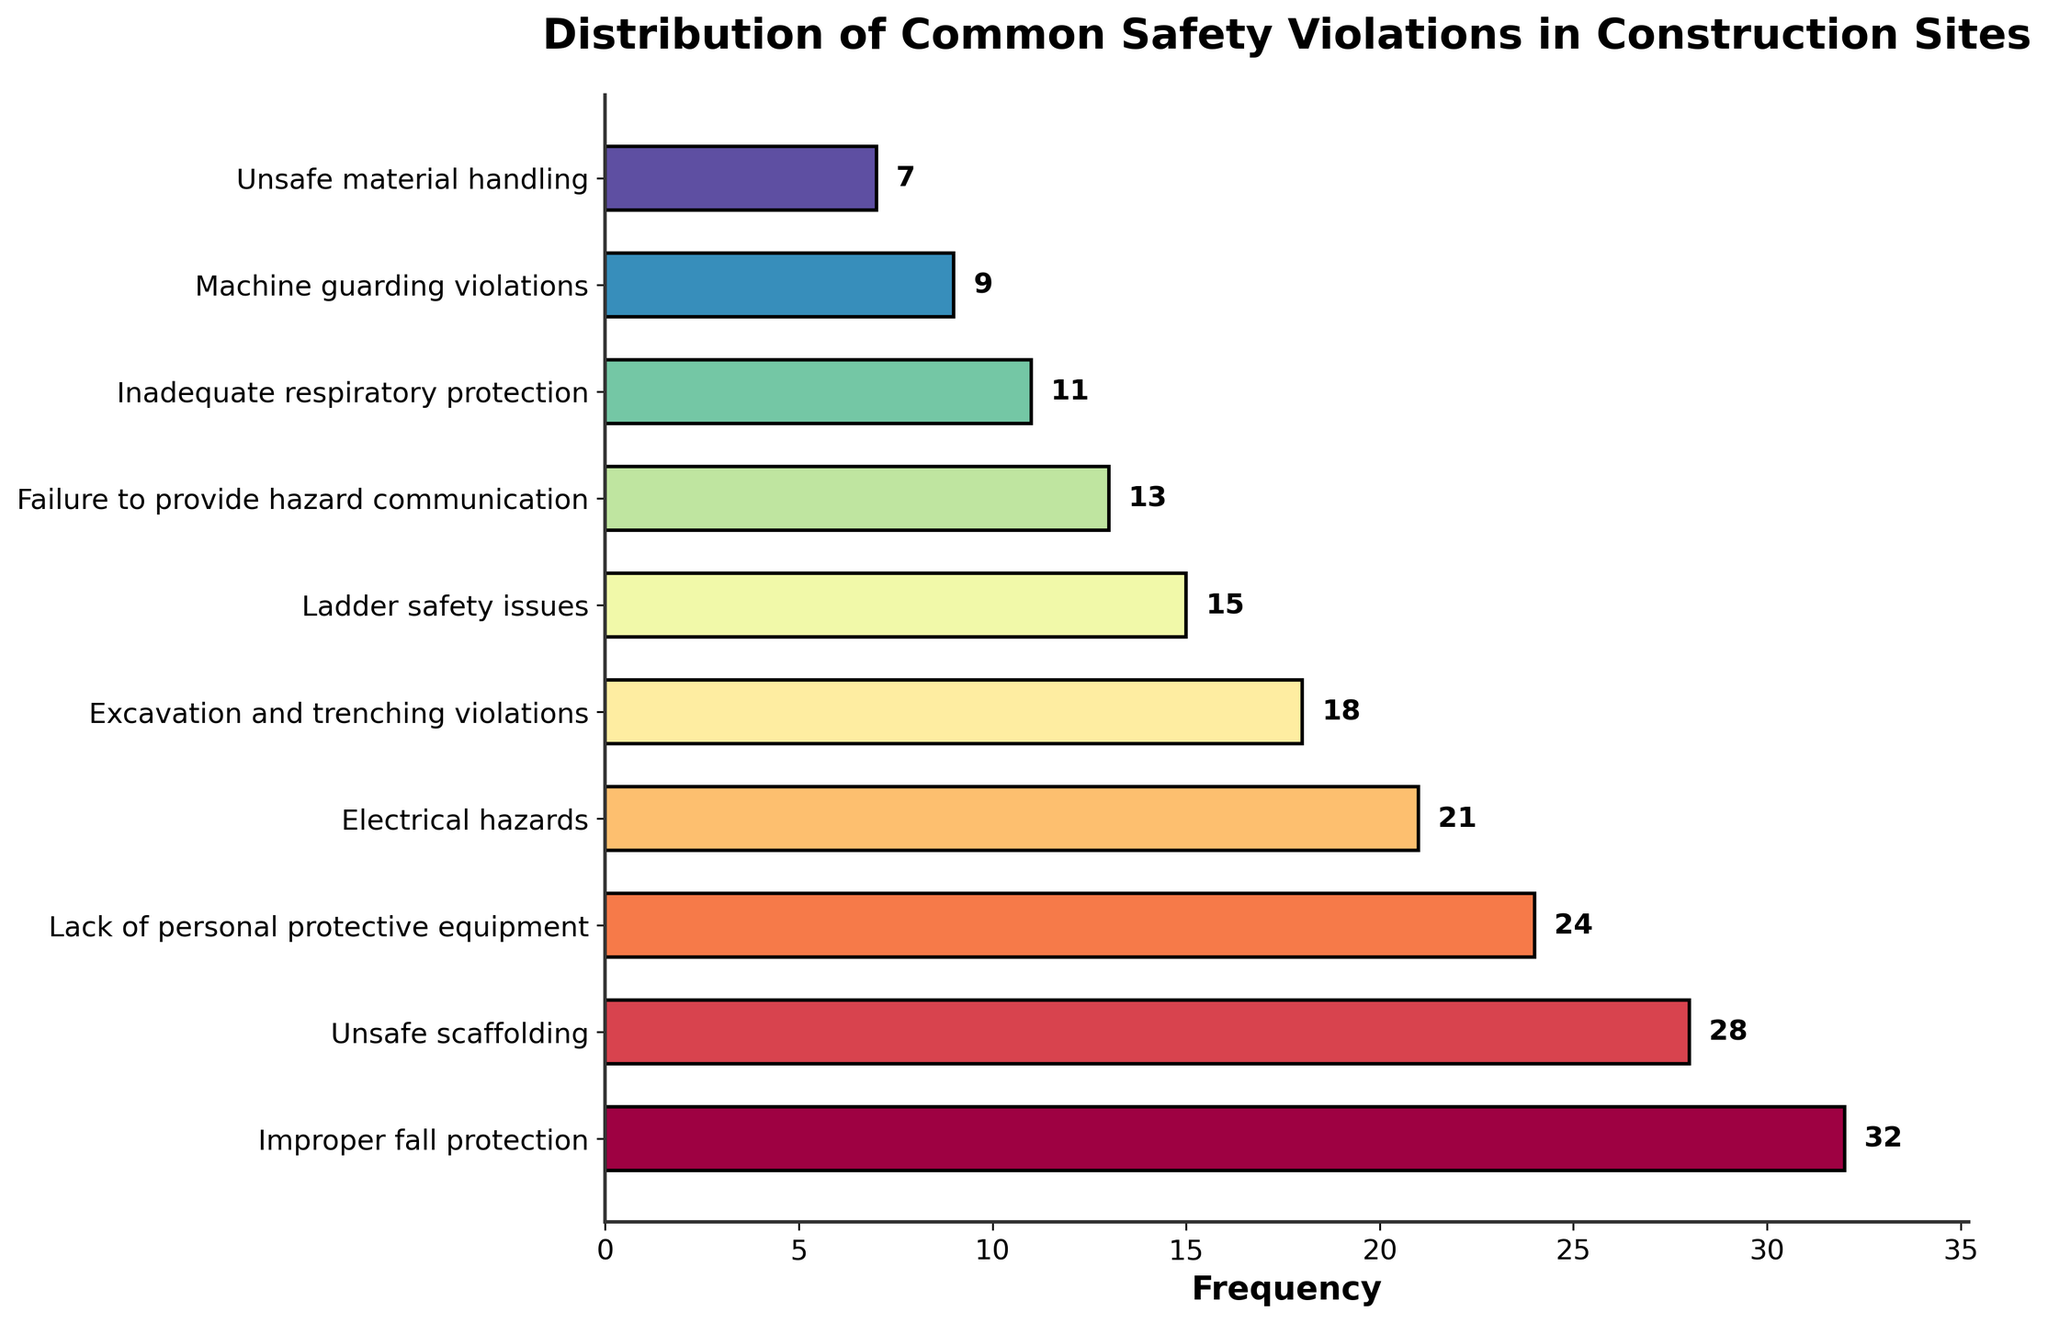Which safety violation has the highest frequency? By looking at the heights of the bars, the tallest one represents "Improper fall protection" with a frequency value of 32 shown beside the bar.
Answer: Improper fall protection What is the combined frequency of "Improper fall protection" and "Unsafe scaffolding"? The frequency of "Improper fall protection" is 32 and the frequency of "Unsafe scaffolding" is 28. Therefore, their combined frequency is 32 + 28.
Answer: 60 How many more incidents of "Lack of personal protective equipment" are there compared to "Unsafe material handling"? The frequency of "Lack of personal protective equipment" is 24, and the frequency of "Unsafe material handling" is 7. The difference is 24 - 7.
Answer: 17 Which violation has a frequency closest to 20? By looking at the frequencies, "Electrical hazards" has a frequency of 21 which is the closest to 20.
Answer: Electrical hazards Among "Inadequate respiratory protection" and "Machine guarding violations," which one is more frequent, and by how much? "Inadequate respiratory protection" has a frequency of 11 and "Machine guarding violations" has a frequency of 9. The difference is 11 - 9.
Answer: Inadequate respiratory protection, 2 What is the average frequency of the top three most common safety violations? The top three most common violations are "Improper fall protection" (32), "Unsafe scaffolding" (28), and "Lack of personal protective equipment" (24). The average frequency is (32 + 28 + 24) / 3.
Answer: 28 Are there more incidents of "Ladder safety issues" or "Failure to provide hazard communication"? "Ladder safety issues" has a frequency of 15, while "Failure to provide hazard communication" has a frequency of 13. 15 is greater than 13.
Answer: Ladder safety issues How many violations have a frequency less than 15? By looking at the frequencies, the violations with less than 15 are "Failure to provide hazard communication" (13), "Inadequate respiratory protection" (11), "Machine guarding violations" (9), and "Unsafe material handling" (7). This results in 4 violations.
Answer: 4 What is the total frequency of all violations that have a frequency greater than 20? The violations with a frequency greater than 20 are "Improper fall protection" (32), "Unsafe scaffolding" (28), and "Lack of personal protective equipment" (24). Their total frequency is 32 + 28 + 24.
Answer: 84 Which violations have a frequency equal to or higher than the median violation frequency? The frequencies are [32, 28, 24, 21, 18, 15, 13, 11, 9, 7]. The median is the average of the 5th and 6th values ((18 + 15) / 2 = 16.5). The violations with frequency equal to or higher than 16.5 are "Improper fall protection" (32), "Unsafe scaffolding" (28), "Lack of personal protective equipment" (24), "Electrical hazards" (21), and "Excavation and trenching violations" (18).
Answer: Improper fall protection, Unsafe scaffolding, Lack of personal protective equipment, Electrical hazards, Excavation and trenching violations 